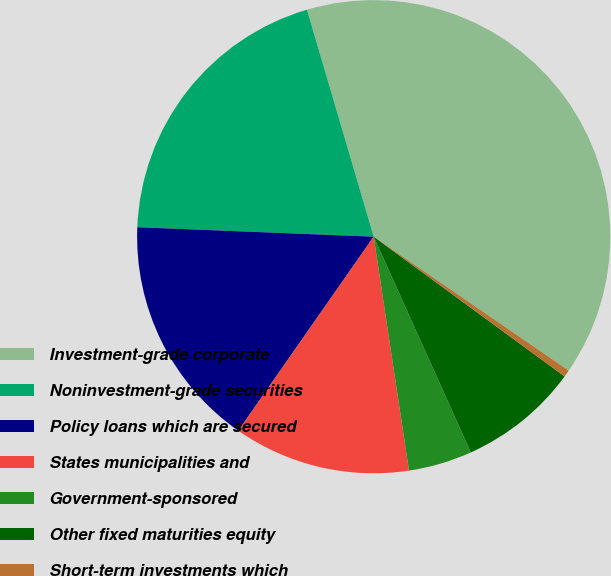Convert chart. <chart><loc_0><loc_0><loc_500><loc_500><pie_chart><fcel>Investment-grade corporate<fcel>Noninvestment-grade securities<fcel>Policy loans which are secured<fcel>States municipalities and<fcel>Government-sponsored<fcel>Other fixed maturities equity<fcel>Short-term investments which<nl><fcel>39.13%<fcel>19.81%<fcel>15.94%<fcel>12.08%<fcel>4.35%<fcel>8.21%<fcel>0.48%<nl></chart> 